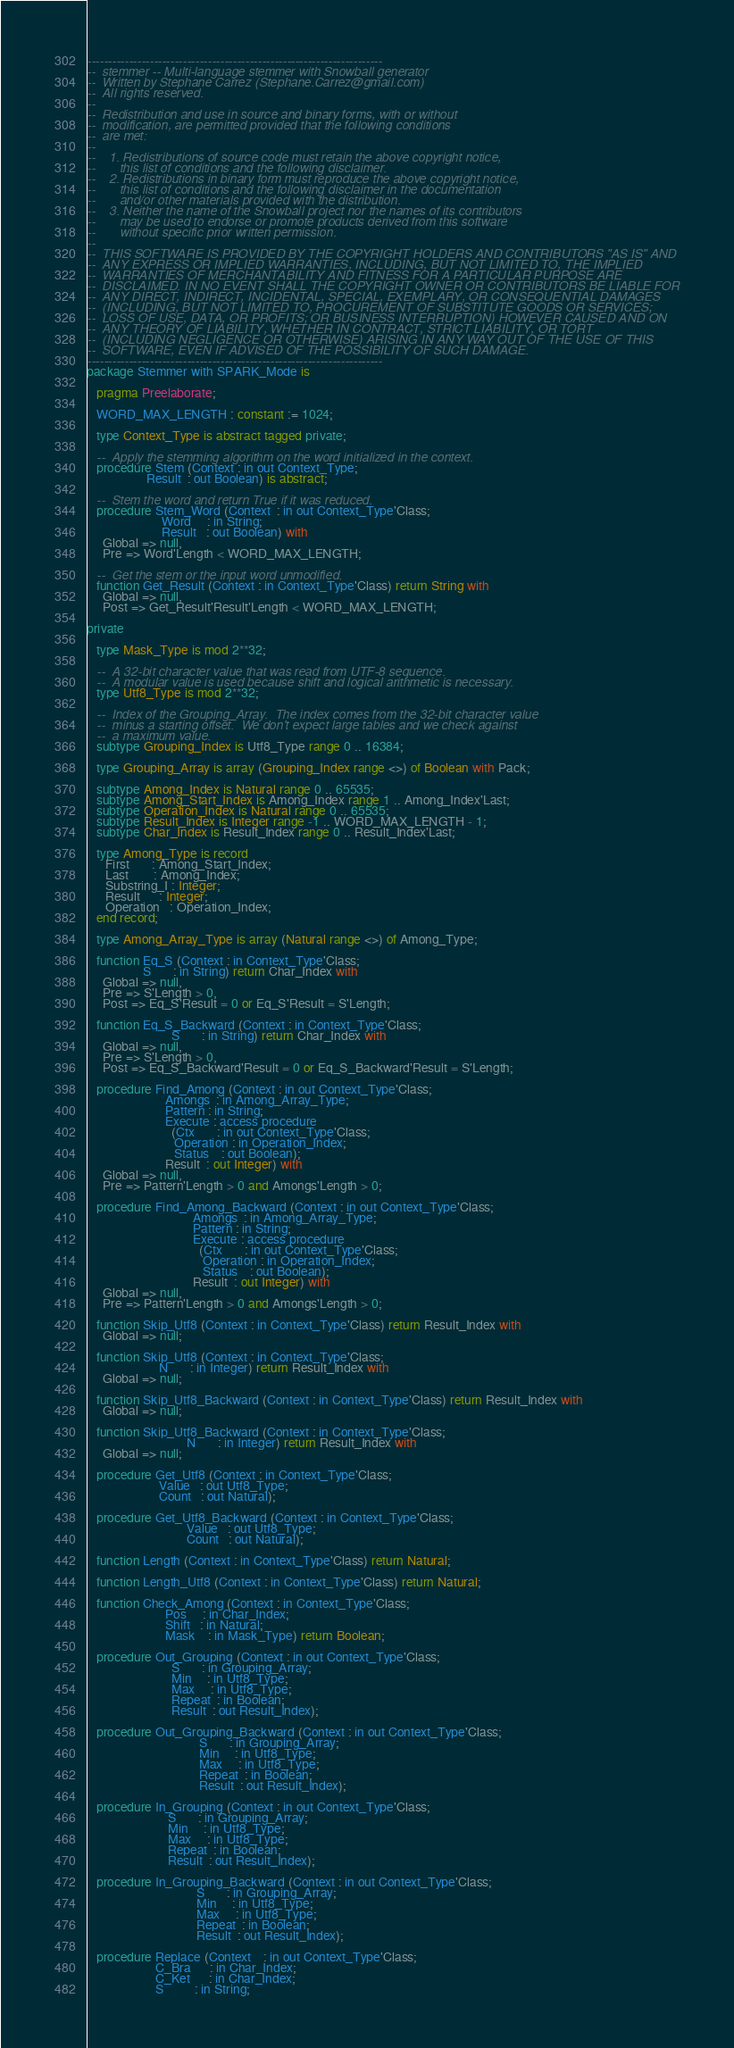Convert code to text. <code><loc_0><loc_0><loc_500><loc_500><_Ada_>-----------------------------------------------------------------------
--  stemmer -- Multi-language stemmer with Snowball generator
--  Written by Stephane Carrez (Stephane.Carrez@gmail.com)
--  All rights reserved.
--
--  Redistribution and use in source and binary forms, with or without
--  modification, are permitted provided that the following conditions
--  are met:
--
--    1. Redistributions of source code must retain the above copyright notice,
--       this list of conditions and the following disclaimer.
--    2. Redistributions in binary form must reproduce the above copyright notice,
--       this list of conditions and the following disclaimer in the documentation
--       and/or other materials provided with the distribution.
--    3. Neither the name of the Snowball project nor the names of its contributors
--       may be used to endorse or promote products derived from this software
--       without specific prior written permission.
--
--  THIS SOFTWARE IS PROVIDED BY THE COPYRIGHT HOLDERS AND CONTRIBUTORS "AS IS" AND
--  ANY EXPRESS OR IMPLIED WARRANTIES, INCLUDING, BUT NOT LIMITED TO, THE IMPLIED
--  WARRANTIES OF MERCHANTABILITY AND FITNESS FOR A PARTICULAR PURPOSE ARE
--  DISCLAIMED. IN NO EVENT SHALL THE COPYRIGHT OWNER OR CONTRIBUTORS BE LIABLE FOR
--  ANY DIRECT, INDIRECT, INCIDENTAL, SPECIAL, EXEMPLARY, OR CONSEQUENTIAL DAMAGES
--  (INCLUDING, BUT NOT LIMITED TO, PROCUREMENT OF SUBSTITUTE GOODS OR SERVICES;
--  LOSS OF USE, DATA, OR PROFITS; OR BUSINESS INTERRUPTION) HOWEVER CAUSED AND ON
--  ANY THEORY OF LIABILITY, WHETHER IN CONTRACT, STRICT LIABILITY, OR TORT
--  (INCLUDING NEGLIGENCE OR OTHERWISE) ARISING IN ANY WAY OUT OF THE USE OF THIS
--  SOFTWARE, EVEN IF ADVISED OF THE POSSIBILITY OF SUCH DAMAGE.
-----------------------------------------------------------------------
package Stemmer with SPARK_Mode is

   pragma Preelaborate;

   WORD_MAX_LENGTH : constant := 1024;

   type Context_Type is abstract tagged private;

   --  Apply the stemming algorithm on the word initialized in the context.
   procedure Stem (Context : in out Context_Type;
                   Result  : out Boolean) is abstract;

   --  Stem the word and return True if it was reduced.
   procedure Stem_Word (Context  : in out Context_Type'Class;
                        Word     : in String;
                        Result   : out Boolean) with
     Global => null,
     Pre => Word'Length < WORD_MAX_LENGTH;

   --  Get the stem or the input word unmodified.
   function Get_Result (Context : in Context_Type'Class) return String with
     Global => null,
     Post => Get_Result'Result'Length < WORD_MAX_LENGTH;

private

   type Mask_Type is mod 2**32;

   --  A 32-bit character value that was read from UTF-8 sequence.
   --  A modular value is used because shift and logical arithmetic is necessary.
   type Utf8_Type is mod 2**32;

   --  Index of the Grouping_Array.  The index comes from the 32-bit character value
   --  minus a starting offset.  We don't expect large tables and we check against
   --  a maximum value.
   subtype Grouping_Index is Utf8_Type range 0 .. 16384;

   type Grouping_Array is array (Grouping_Index range <>) of Boolean with Pack;

   subtype Among_Index is Natural range 0 .. 65535;
   subtype Among_Start_Index is Among_Index range 1 .. Among_Index'Last;
   subtype Operation_Index is Natural range 0 .. 65535;
   subtype Result_Index is Integer range -1 .. WORD_MAX_LENGTH - 1;
   subtype Char_Index is Result_Index range 0 .. Result_Index'Last;

   type Among_Type is record
      First       : Among_Start_Index;
      Last        : Among_Index;
      Substring_I : Integer;
      Result      : Integer;
      Operation   : Operation_Index;
   end record;

   type Among_Array_Type is array (Natural range <>) of Among_Type;

   function Eq_S (Context : in Context_Type'Class;
                  S       : in String) return Char_Index with
     Global => null,
     Pre => S'Length > 0,
     Post => Eq_S'Result = 0 or Eq_S'Result = S'Length;

   function Eq_S_Backward (Context : in Context_Type'Class;
                           S       : in String) return Char_Index with
     Global => null,
     Pre => S'Length > 0,
     Post => Eq_S_Backward'Result = 0 or Eq_S_Backward'Result = S'Length;

   procedure Find_Among (Context : in out Context_Type'Class;
                         Amongs  : in Among_Array_Type;
                         Pattern : in String;
                         Execute : access procedure
                           (Ctx       : in out Context_Type'Class;
                            Operation : in Operation_Index;
                            Status    : out Boolean);
                         Result  : out Integer) with
     Global => null,
     Pre => Pattern'Length > 0 and Amongs'Length > 0;

   procedure Find_Among_Backward (Context : in out Context_Type'Class;
                                  Amongs  : in Among_Array_Type;
                                  Pattern : in String;
                                  Execute : access procedure
                                    (Ctx       : in out Context_Type'Class;
                                     Operation : in Operation_Index;
                                     Status    : out Boolean);
                                  Result  : out Integer) with
     Global => null,
     Pre => Pattern'Length > 0 and Amongs'Length > 0;

   function Skip_Utf8 (Context : in Context_Type'Class) return Result_Index with
     Global => null;

   function Skip_Utf8 (Context : in Context_Type'Class;
                       N       : in Integer) return Result_Index with
     Global => null;

   function Skip_Utf8_Backward (Context : in Context_Type'Class) return Result_Index with
     Global => null;

   function Skip_Utf8_Backward (Context : in Context_Type'Class;
                                N       : in Integer) return Result_Index with
     Global => null;

   procedure Get_Utf8 (Context : in Context_Type'Class;
                       Value   : out Utf8_Type;
                       Count   : out Natural);

   procedure Get_Utf8_Backward (Context : in Context_Type'Class;
                                Value   : out Utf8_Type;
                                Count   : out Natural);

   function Length (Context : in Context_Type'Class) return Natural;

   function Length_Utf8 (Context : in Context_Type'Class) return Natural;

   function Check_Among (Context : in Context_Type'Class;
                         Pos     : in Char_Index;
                         Shift   : in Natural;
                         Mask    : in Mask_Type) return Boolean;

   procedure Out_Grouping (Context : in out Context_Type'Class;
                           S       : in Grouping_Array;
                           Min     : in Utf8_Type;
                           Max     : in Utf8_Type;
                           Repeat  : in Boolean;
                           Result  : out Result_Index);

   procedure Out_Grouping_Backward (Context : in out Context_Type'Class;
                                    S       : in Grouping_Array;
                                    Min     : in Utf8_Type;
                                    Max     : in Utf8_Type;
                                    Repeat  : in Boolean;
                                    Result  : out Result_Index);

   procedure In_Grouping (Context : in out Context_Type'Class;
                          S       : in Grouping_Array;
                          Min     : in Utf8_Type;
                          Max     : in Utf8_Type;
                          Repeat  : in Boolean;
                          Result  : out Result_Index);

   procedure In_Grouping_Backward (Context : in out Context_Type'Class;
                                   S       : in Grouping_Array;
                                   Min     : in Utf8_Type;
                                   Max     : in Utf8_Type;
                                   Repeat  : in Boolean;
                                   Result  : out Result_Index);

   procedure Replace (Context    : in out Context_Type'Class;
                      C_Bra      : in Char_Index;
                      C_Ket      : in Char_Index;
                      S          : in String;</code> 